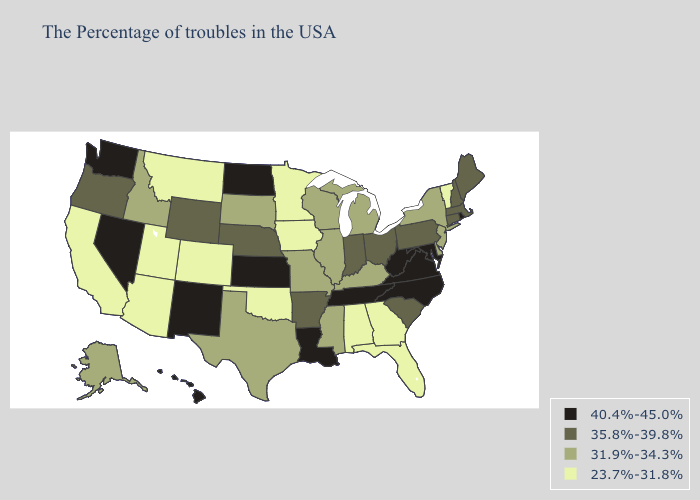What is the lowest value in states that border Kentucky?
Quick response, please. 31.9%-34.3%. What is the lowest value in the Northeast?
Answer briefly. 23.7%-31.8%. Name the states that have a value in the range 40.4%-45.0%?
Keep it brief. Rhode Island, Maryland, Virginia, North Carolina, West Virginia, Tennessee, Louisiana, Kansas, North Dakota, New Mexico, Nevada, Washington, Hawaii. What is the value of Arkansas?
Write a very short answer. 35.8%-39.8%. Name the states that have a value in the range 31.9%-34.3%?
Concise answer only. New York, New Jersey, Delaware, Michigan, Kentucky, Wisconsin, Illinois, Mississippi, Missouri, Texas, South Dakota, Idaho, Alaska. Which states have the lowest value in the USA?
Short answer required. Vermont, Florida, Georgia, Alabama, Minnesota, Iowa, Oklahoma, Colorado, Utah, Montana, Arizona, California. What is the value of Hawaii?
Keep it brief. 40.4%-45.0%. Does the first symbol in the legend represent the smallest category?
Concise answer only. No. Name the states that have a value in the range 23.7%-31.8%?
Keep it brief. Vermont, Florida, Georgia, Alabama, Minnesota, Iowa, Oklahoma, Colorado, Utah, Montana, Arizona, California. Among the states that border Minnesota , which have the highest value?
Write a very short answer. North Dakota. Name the states that have a value in the range 40.4%-45.0%?
Write a very short answer. Rhode Island, Maryland, Virginia, North Carolina, West Virginia, Tennessee, Louisiana, Kansas, North Dakota, New Mexico, Nevada, Washington, Hawaii. Name the states that have a value in the range 31.9%-34.3%?
Quick response, please. New York, New Jersey, Delaware, Michigan, Kentucky, Wisconsin, Illinois, Mississippi, Missouri, Texas, South Dakota, Idaho, Alaska. What is the lowest value in the West?
Short answer required. 23.7%-31.8%. Name the states that have a value in the range 35.8%-39.8%?
Write a very short answer. Maine, Massachusetts, New Hampshire, Connecticut, Pennsylvania, South Carolina, Ohio, Indiana, Arkansas, Nebraska, Wyoming, Oregon. How many symbols are there in the legend?
Be succinct. 4. 